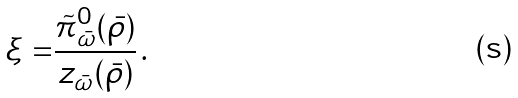<formula> <loc_0><loc_0><loc_500><loc_500>\xi = & \frac { \tilde { \pi } _ { \bar { \omega } } ^ { 0 } ( \bar { \rho } ) } { z _ { \bar { \omega } } ( \bar { \rho } ) } \, .</formula> 